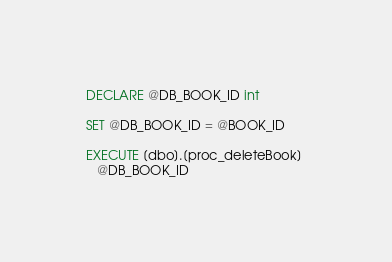Convert code to text. <code><loc_0><loc_0><loc_500><loc_500><_SQL_>DECLARE @DB_BOOK_ID int

SET @DB_BOOK_ID = @BOOK_ID

EXECUTE [dbo].[proc_deleteBook] 
   @DB_BOOK_ID</code> 